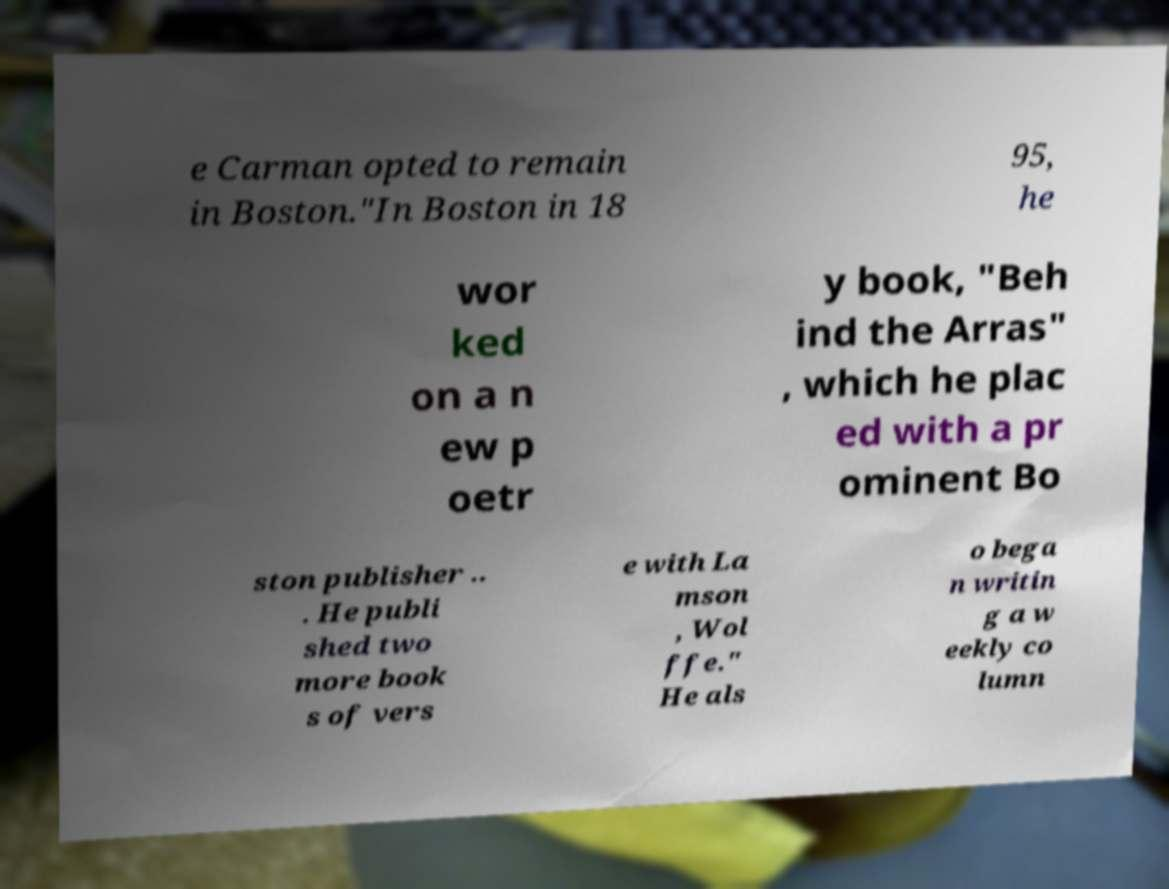Please identify and transcribe the text found in this image. e Carman opted to remain in Boston."In Boston in 18 95, he wor ked on a n ew p oetr y book, "Beh ind the Arras" , which he plac ed with a pr ominent Bo ston publisher .. . He publi shed two more book s of vers e with La mson , Wol ffe." He als o bega n writin g a w eekly co lumn 